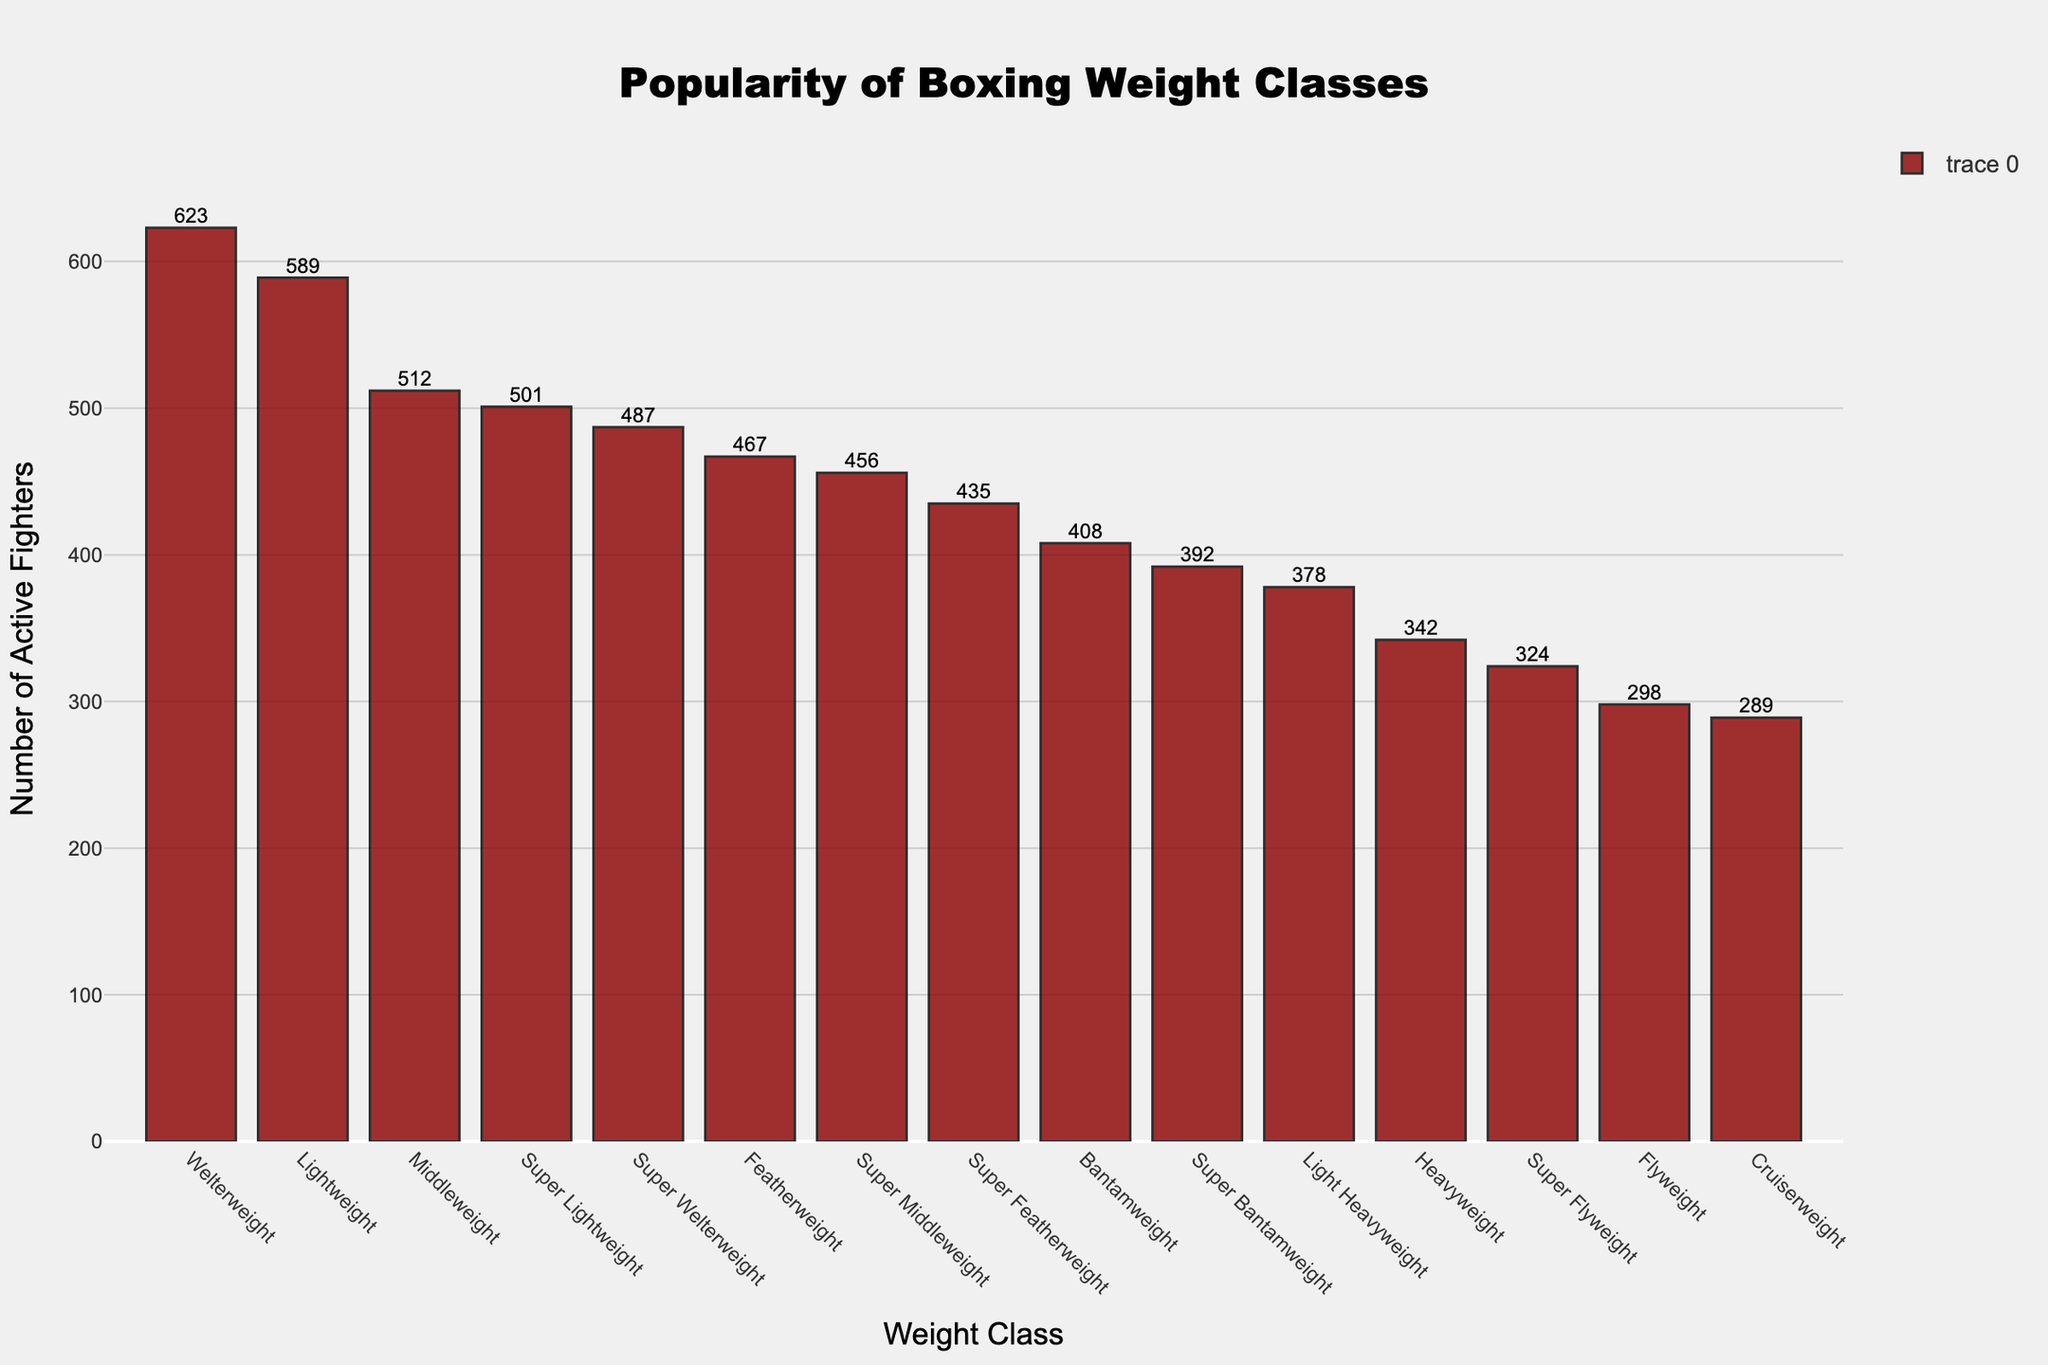Which weight class has the most active fighters? By looking at the height of the bars, the bar for the Welterweight class is the tallest. Thus, Welterweight has the most active fighters.
Answer: Welterweight What is the total number of active fighters in the Super Lightweight and Lightweight classes combined? The Super Lightweight class has 501 active fighters, and the Lightweight class has 589 active fighters. Adding them together gives 501 + 589 = 1090.
Answer: 1090 Which class has more active fighters, Featherweight or Super Bantamweight? By comparing the heights of the bars for Featherweight and Super Bantamweight, the Featherweight bar is taller. Hence, Featherweight has more active fighters.
Answer: Featherweight How many more fighters are in the Middleweight class compared to the Cruiserweight class? The Middleweight class has 512 active fighters, and the Cruiserweight class has 289 active fighters. Subtracting these numbers gives 512 - 289 = 223.
Answer: 223 Which weight classes have fewer than 350 active fighters? The weight classes with fewer than 350 active fighters are Cruiserweight (289), Super Flyweight (324), and Flyweight (298).
Answer: Cruiserweight, Super Flyweight, Flyweight What is the average number of active fighters across the Heavyweight, Cruiserweight, and Light Heavyweight classes? Adding the number of active fighters in Heavyweight (342), Cruiserweight (289), and Light Heavyweight (378) equals 342 + 289 + 378 = 1009. Dividing by 3 gives 1009 / 3 ≈ 336.33.
Answer: 336.33 Is the number of active fighters in the Super Featherweight class greater than or equal to 400? The number of active fighters in the Super Featherweight class is 435, which is greater than 400.
Answer: Yes By how much does the number of active fighters in the Welterweight class exceed the number of active fighters in the Bantamweight class? The number of active fighters in the Welterweight class is 623, and in the Bantamweight class, it is 408. Subtracting these gives 623 - 408 = 215.
Answer: 215 What is the median number of active fighters across all weight classes? Ordering the number of active fighters: 289, 298, 324, 342, 378, 392, 408, 435, 456, 467, 487, 501, 512, 589, 623. The median value is the 8th value, which is 435.
Answer: 435 